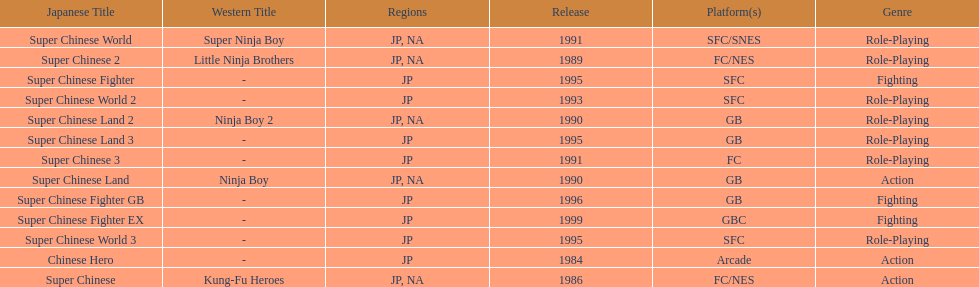Would you be able to parse every entry in this table? {'header': ['Japanese Title', 'Western Title', 'Regions', 'Release', 'Platform(s)', 'Genre'], 'rows': [['Super Chinese World', 'Super Ninja Boy', 'JP, NA', '1991', 'SFC/SNES', 'Role-Playing'], ['Super Chinese 2', 'Little Ninja Brothers', 'JP, NA', '1989', 'FC/NES', 'Role-Playing'], ['Super Chinese Fighter', '-', 'JP', '1995', 'SFC', 'Fighting'], ['Super Chinese World 2', '-', 'JP', '1993', 'SFC', 'Role-Playing'], ['Super Chinese Land 2', 'Ninja Boy 2', 'JP, NA', '1990', 'GB', 'Role-Playing'], ['Super Chinese Land 3', '-', 'JP', '1995', 'GB', 'Role-Playing'], ['Super Chinese 3', '-', 'JP', '1991', 'FC', 'Role-Playing'], ['Super Chinese Land', 'Ninja Boy', 'JP, NA', '1990', 'GB', 'Action'], ['Super Chinese Fighter GB', '-', 'JP', '1996', 'GB', 'Fighting'], ['Super Chinese Fighter EX', '-', 'JP', '1999', 'GBC', 'Fighting'], ['Super Chinese World 3', '-', 'JP', '1995', 'SFC', 'Role-Playing'], ['Chinese Hero', '-', 'JP', '1984', 'Arcade', 'Action'], ['Super Chinese', 'Kung-Fu Heroes', 'JP, NA', '1986', 'FC/NES', 'Action']]} What are the total of super chinese games released? 13. 